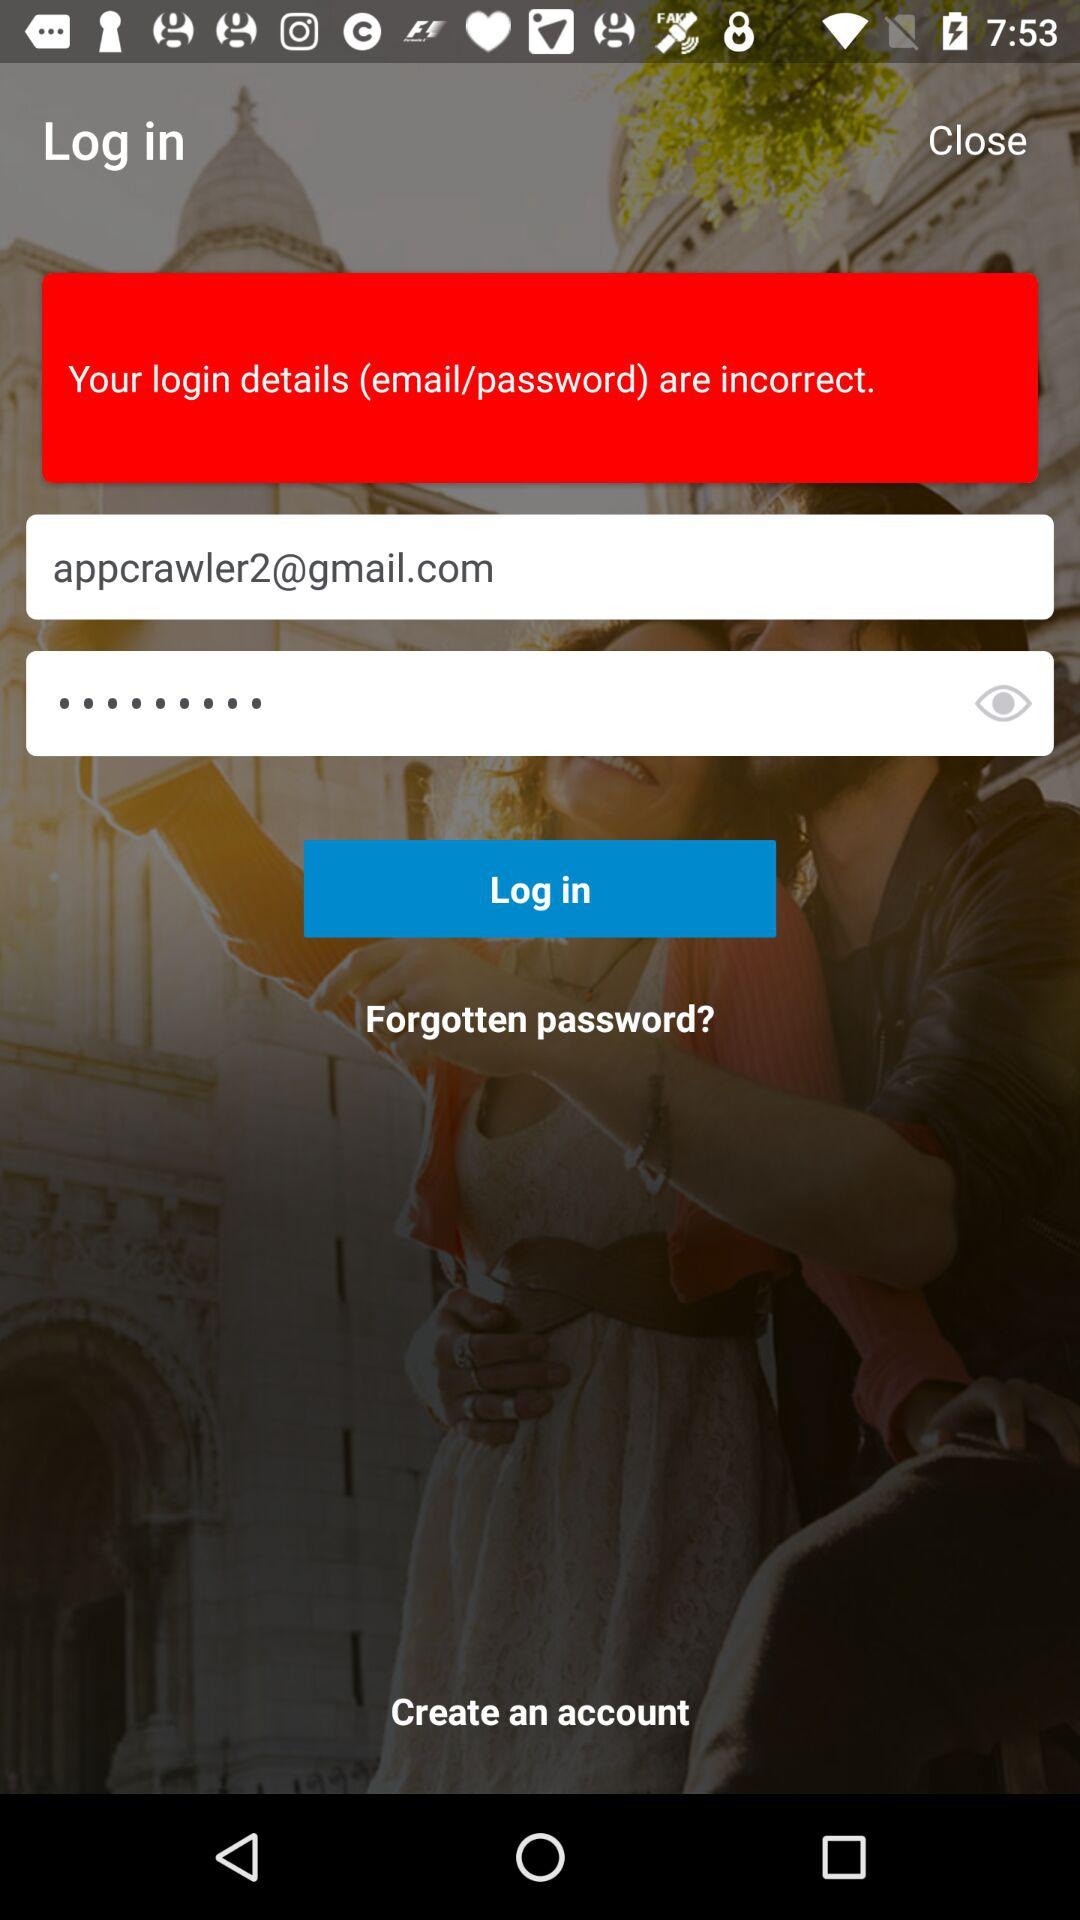Is a personal email address required to create an account?
When the provided information is insufficient, respond with <no answer>. <no answer> 